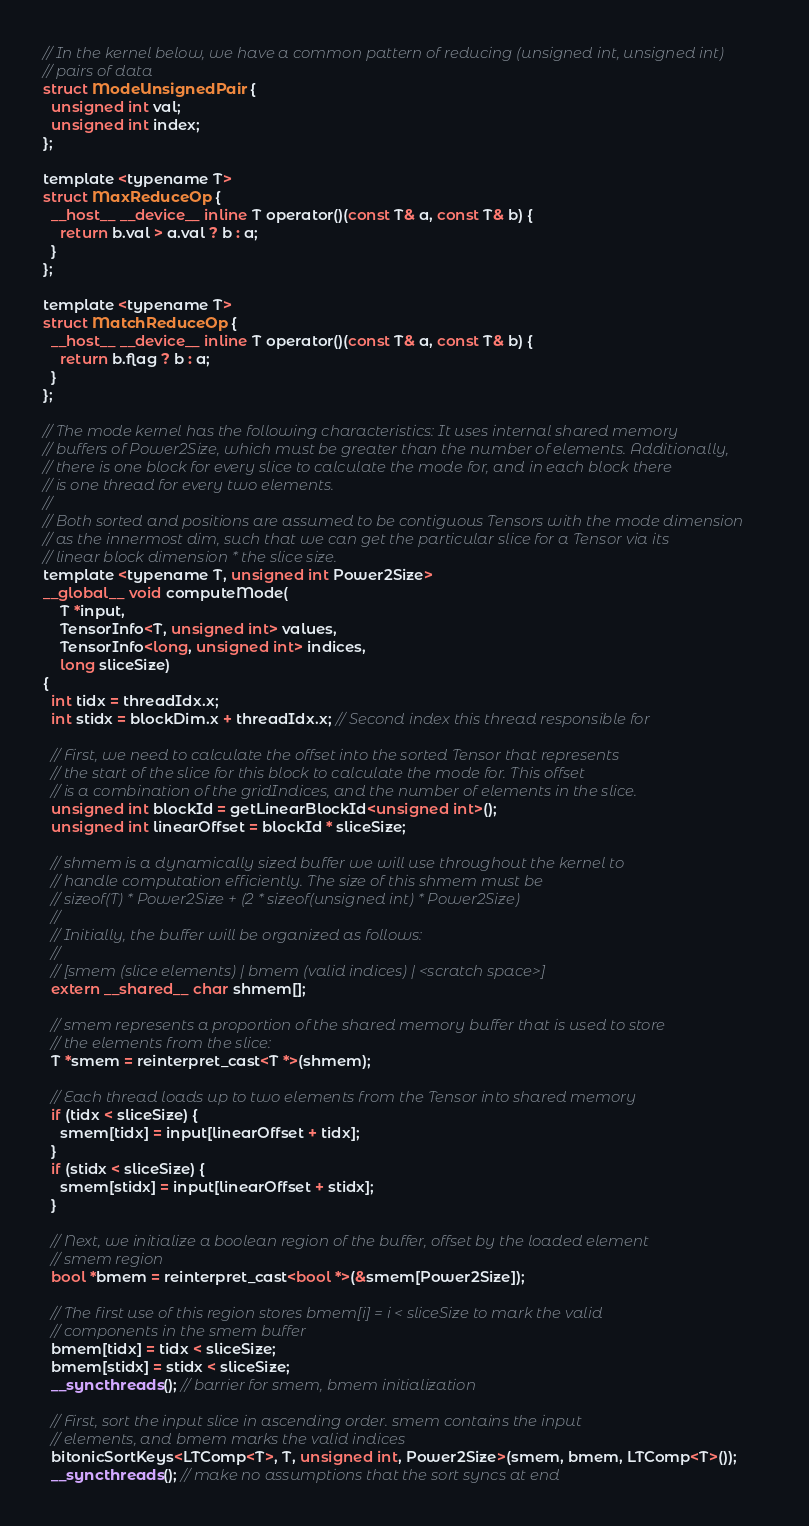Convert code to text. <code><loc_0><loc_0><loc_500><loc_500><_Cuda_>// In the kernel below, we have a common pattern of reducing (unsigned int, unsigned int)
// pairs of data
struct ModeUnsignedPair {
  unsigned int val;
  unsigned int index;
};

template <typename T>
struct MaxReduceOp {
  __host__ __device__ inline T operator()(const T& a, const T& b) {
    return b.val > a.val ? b : a;
  }
};

template <typename T>
struct MatchReduceOp {
  __host__ __device__ inline T operator()(const T& a, const T& b) {
    return b.flag ? b : a;
  }
};

// The mode kernel has the following characteristics: It uses internal shared memory
// buffers of Power2Size, which must be greater than the number of elements. Additionally,
// there is one block for every slice to calculate the mode for, and in each block there
// is one thread for every two elements.
//
// Both sorted and positions are assumed to be contiguous Tensors with the mode dimension
// as the innermost dim, such that we can get the particular slice for a Tensor via its
// linear block dimension * the slice size.
template <typename T, unsigned int Power2Size>
__global__ void computeMode(
    T *input,
    TensorInfo<T, unsigned int> values,
    TensorInfo<long, unsigned int> indices,
    long sliceSize)
{
  int tidx = threadIdx.x;
  int stidx = blockDim.x + threadIdx.x; // Second index this thread responsible for

  // First, we need to calculate the offset into the sorted Tensor that represents
  // the start of the slice for this block to calculate the mode for. This offset
  // is a combination of the gridIndices, and the number of elements in the slice.
  unsigned int blockId = getLinearBlockId<unsigned int>();
  unsigned int linearOffset = blockId * sliceSize;

  // shmem is a dynamically sized buffer we will use throughout the kernel to
  // handle computation efficiently. The size of this shmem must be
  // sizeof(T) * Power2Size + (2 * sizeof(unsigned int) * Power2Size)
  //
  // Initially, the buffer will be organized as follows:
  //
  // [smem (slice elements) | bmem (valid indices) | <scratch space>]
  extern __shared__ char shmem[];

  // smem represents a proportion of the shared memory buffer that is used to store
  // the elements from the slice:
  T *smem = reinterpret_cast<T *>(shmem);

  // Each thread loads up to two elements from the Tensor into shared memory
  if (tidx < sliceSize) {
    smem[tidx] = input[linearOffset + tidx];
  }
  if (stidx < sliceSize) {
    smem[stidx] = input[linearOffset + stidx];
  }

  // Next, we initialize a boolean region of the buffer, offset by the loaded element
  // smem region
  bool *bmem = reinterpret_cast<bool *>(&smem[Power2Size]);

  // The first use of this region stores bmem[i] = i < sliceSize to mark the valid
  // components in the smem buffer
  bmem[tidx] = tidx < sliceSize;
  bmem[stidx] = stidx < sliceSize;
  __syncthreads(); // barrier for smem, bmem initialization

  // First, sort the input slice in ascending order. smem contains the input
  // elements, and bmem marks the valid indices
  bitonicSortKeys<LTComp<T>, T, unsigned int, Power2Size>(smem, bmem, LTComp<T>());
  __syncthreads(); // make no assumptions that the sort syncs at end
</code> 